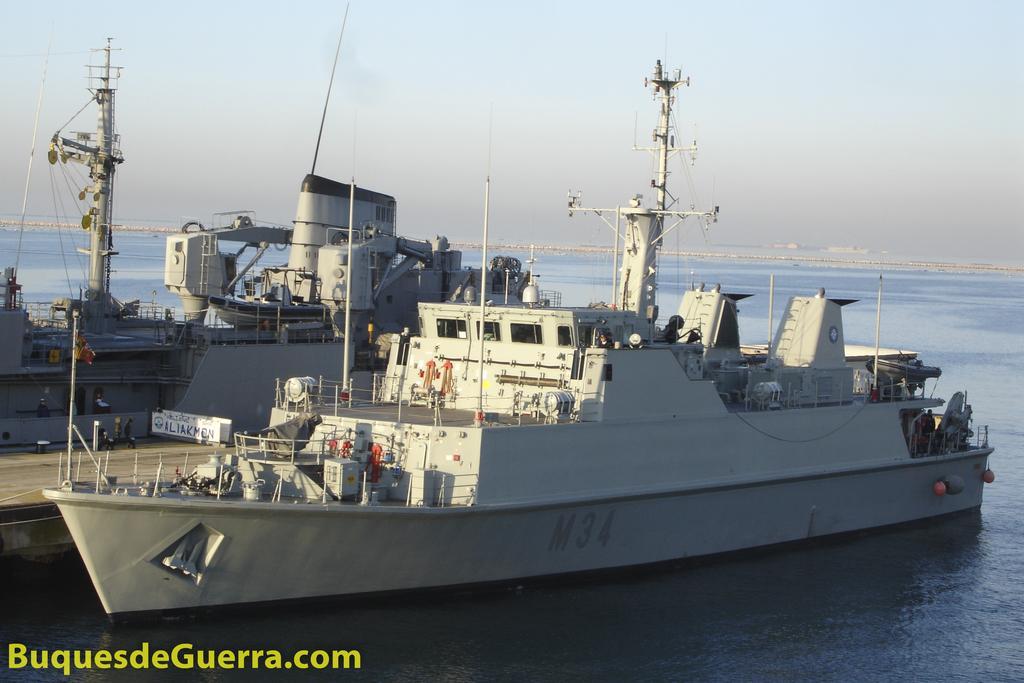Describe this image in one or two sentences. In this image we can see ships on the water. In the background there is sky. At the bottom of the image we can see a watermark. 